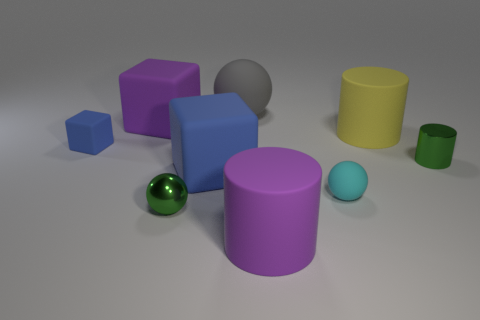There is a green object right of the large gray sphere to the left of the large purple rubber cylinder; what size is it?
Offer a terse response. Small. Are there more big matte blocks than yellow rubber cylinders?
Provide a succinct answer. Yes. Is the number of metal cylinders in front of the large blue thing greater than the number of tiny blue rubber things that are left of the tiny blue object?
Provide a succinct answer. No. There is a rubber cube that is both right of the tiny block and behind the green metal cylinder; what size is it?
Make the answer very short. Large. How many blocks have the same size as the gray sphere?
Offer a terse response. 2. There is a thing that is the same color as the tiny metal ball; what material is it?
Ensure brevity in your answer.  Metal. There is a purple matte thing that is in front of the yellow rubber cylinder; does it have the same shape as the cyan object?
Ensure brevity in your answer.  No. Are there fewer large purple cubes in front of the purple rubber cube than tiny gray matte blocks?
Offer a terse response. No. Is there a big shiny block that has the same color as the tiny cube?
Give a very brief answer. No. Do the tiny cyan object and the blue matte object that is in front of the tiny blue block have the same shape?
Make the answer very short. No. 